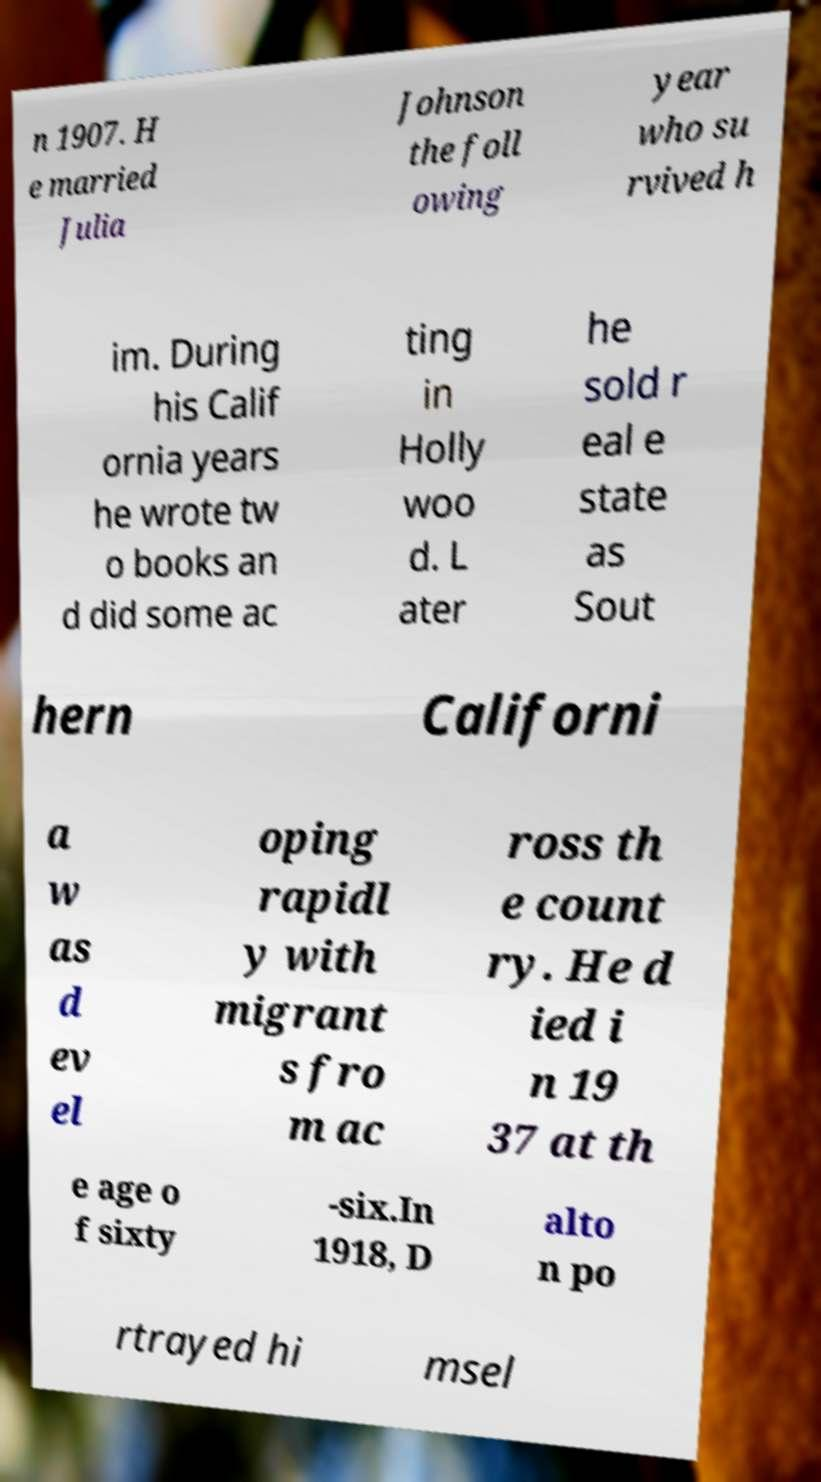I need the written content from this picture converted into text. Can you do that? n 1907. H e married Julia Johnson the foll owing year who su rvived h im. During his Calif ornia years he wrote tw o books an d did some ac ting in Holly woo d. L ater he sold r eal e state as Sout hern Californi a w as d ev el oping rapidl y with migrant s fro m ac ross th e count ry. He d ied i n 19 37 at th e age o f sixty -six.In 1918, D alto n po rtrayed hi msel 